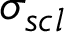Convert formula to latex. <formula><loc_0><loc_0><loc_500><loc_500>\sigma _ { s c l }</formula> 